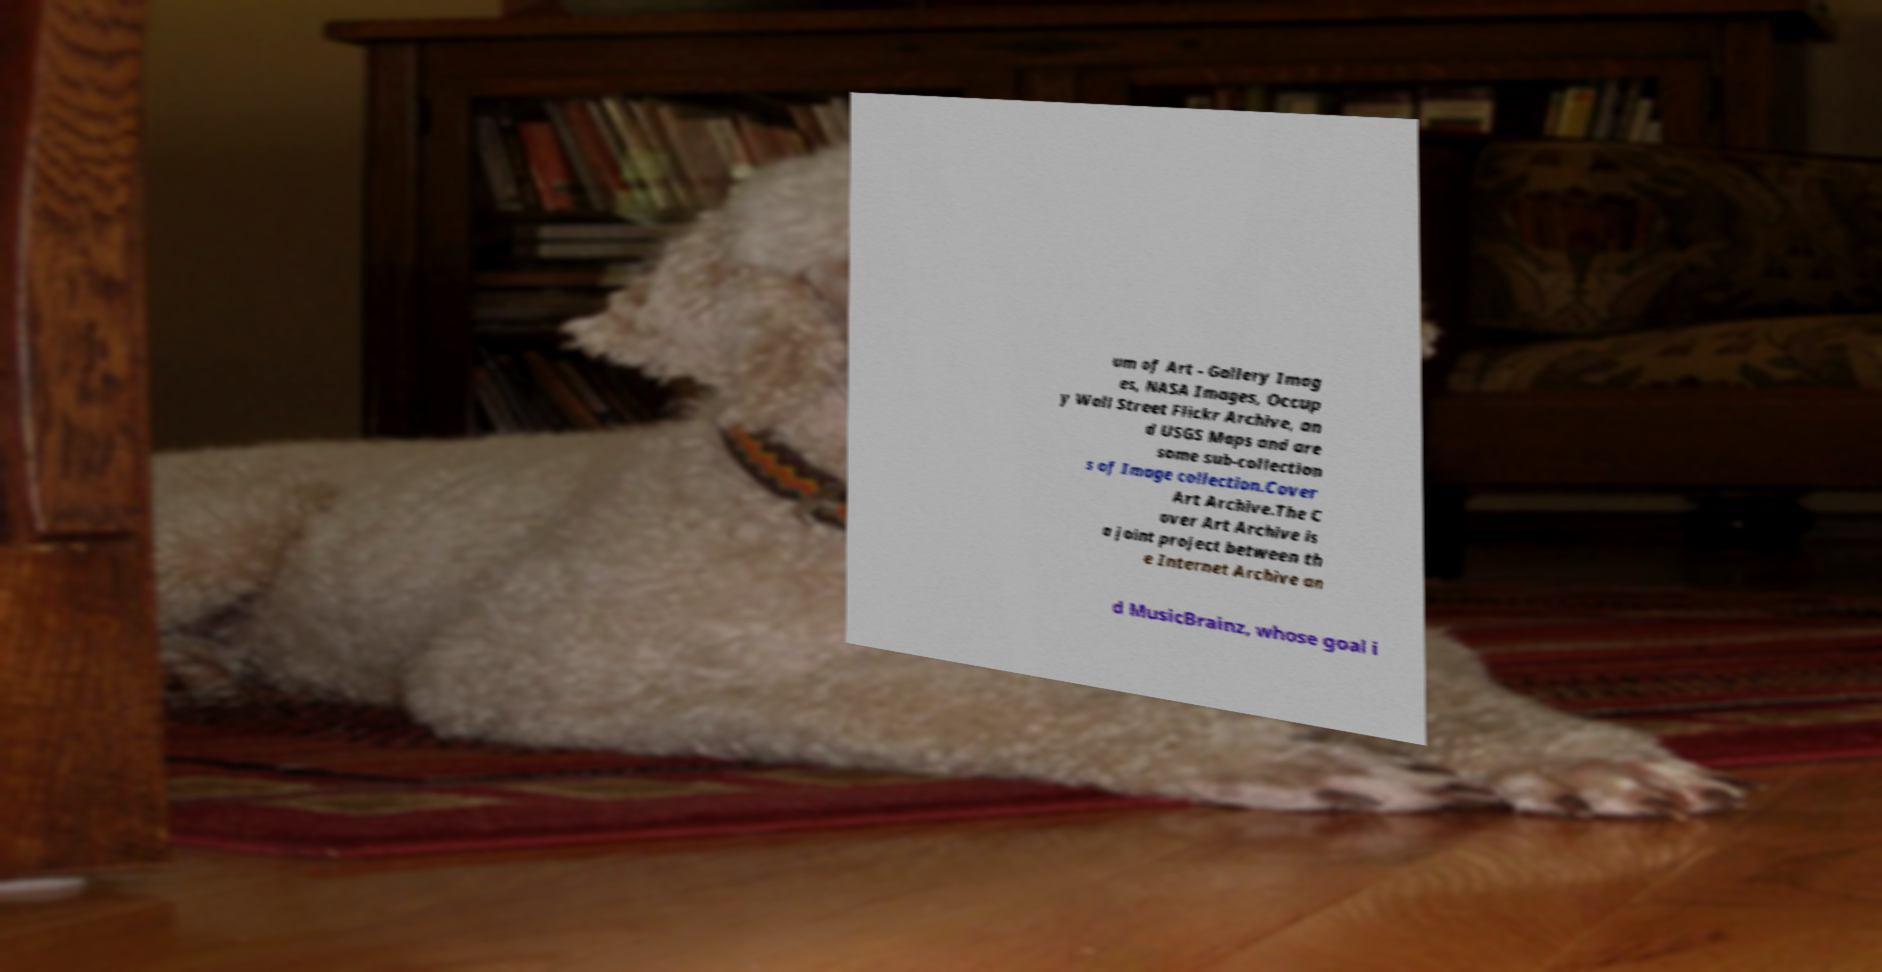Could you extract and type out the text from this image? um of Art - Gallery Imag es, NASA Images, Occup y Wall Street Flickr Archive, an d USGS Maps and are some sub-collection s of Image collection.Cover Art Archive.The C over Art Archive is a joint project between th e Internet Archive an d MusicBrainz, whose goal i 